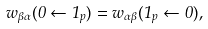Convert formula to latex. <formula><loc_0><loc_0><loc_500><loc_500>w _ { \beta \alpha } ( 0 \leftarrow 1 _ { p } ) = w _ { \alpha \beta } ( 1 _ { p } \leftarrow 0 ) ,</formula> 